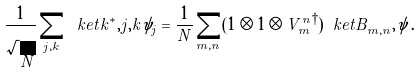Convert formula to latex. <formula><loc_0><loc_0><loc_500><loc_500>\frac { 1 } { \sqrt { N } } \sum _ { j , k } \ k e t { k ^ { * } , j , k } \psi _ { j } = \frac { 1 } { N } \sum _ { m , n } ( 1 \otimes 1 \otimes { V _ { m } ^ { n } } ^ { \dagger } ) \ k e t { B ^ { \ } _ { m , n } , \psi } \, .</formula> 